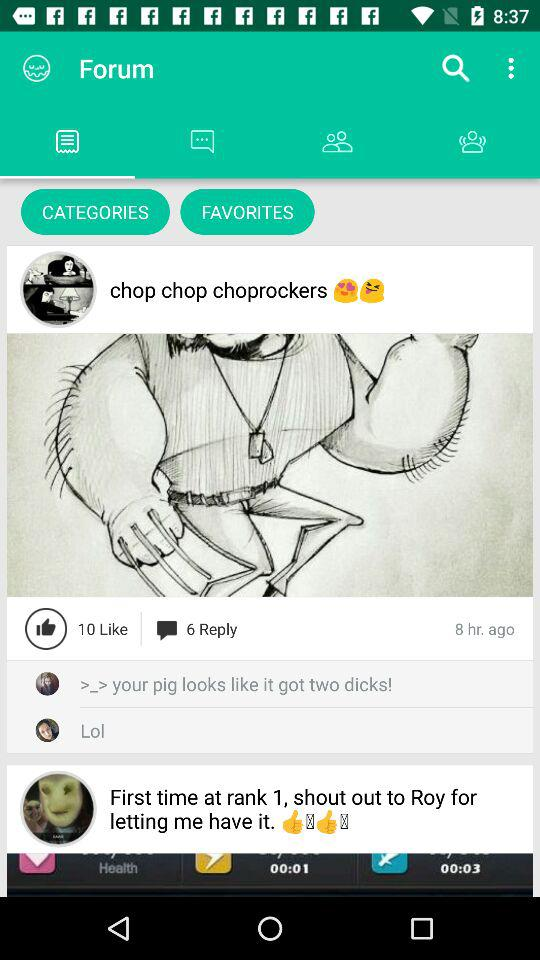How many likes are there of the post posted by "chop chop choprockers"? There are 10 likes. 